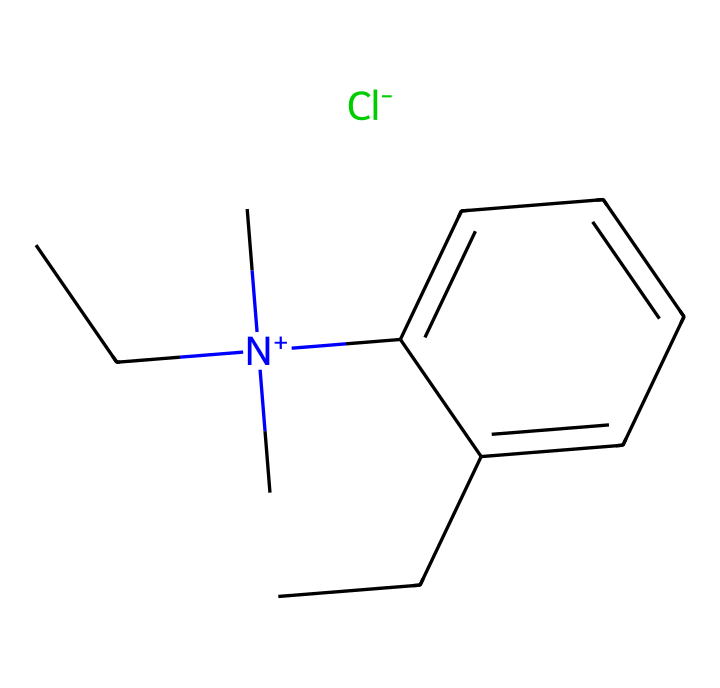What is the molecular formula of benzalkonium chloride? To find the molecular formula, we need to count the number of each type of atom from the SMILES representation provided: C (carbon), H (hydrogen), N (nitrogen), and Cl (chlorine). The structure indicates there are 16 carbons, 34 hydrogens, 1 nitrogen, and 1 chlorine. Thus, the molecular formula is C16H34ClN.
Answer: C16H34ClN How many carbon atoms are present in this compound? By examining the SMILES, we can identify the carbon atoms by counting each occurrence of 'C'. There are 16 'C' symbols in the representation, indicating that there are 16 carbon atoms in the molecule.
Answer: 16 Which atom is responsible for the positive charge in benzalkonium chloride? The nitrogen atom is represented by [N+] in the SMILES, indicating it carries a positive charge. The presence of the positive charge is specifically denoted next to the nitrogen atom, confirming its role as the cationic component of this surfactant.
Answer: Nitrogen What type of surfactant is benzalkonium chloride? The positive charge on the nitrogen atom indicates that benzalkonium chloride is a cationic surfactant, which is known for its antimicrobial properties and ability to interact with negatively charged surfaces such as bacteria and viruses.
Answer: Cationic What functional group is present in benzalkonium chloride? The presence of the nitrogen atom bonded to three carbon chains indicates a quaternary ammonium group, which is characteristic of this surfactant. This functional group is essential for its antimicrobial properties and behavior as a surfactant.
Answer: Quaternary ammonium How does the structure contribute to its antimicrobial properties? The long hydrocarbon chains (the alkyl groups) provide lipophilicity, allowing the compound to disrupt microbial membranes. Additionally, the positively charged nitrogen can interact with negatively charged components of microbial cells, enhancing its antimicrobial activity.
Answer: Disruption of membranes What is the significance of the chlorine atom in this structure? The chlorine atom is part of the ionic interaction, which helps in solubility of the surfactant in water. It also plays a role in the overall stability of the molecule, impacting its efficacy as a disinfectant.
Answer: Solubility and stability 